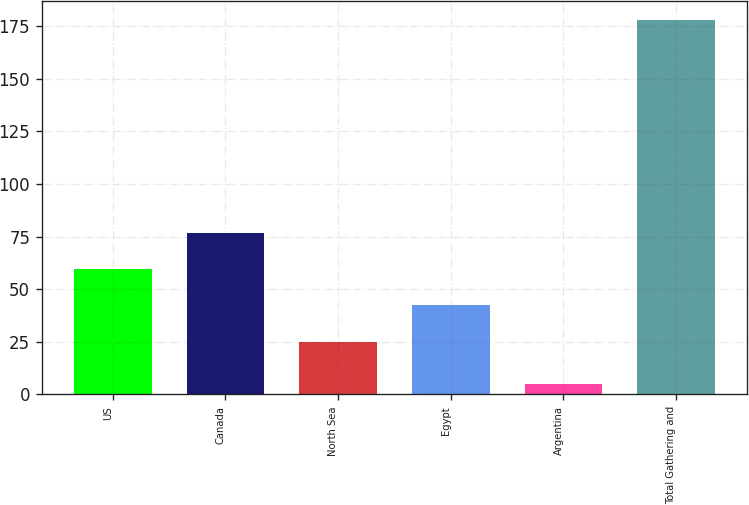<chart> <loc_0><loc_0><loc_500><loc_500><bar_chart><fcel>US<fcel>Canada<fcel>North Sea<fcel>Egypt<fcel>Argentina<fcel>Total Gathering and<nl><fcel>59.6<fcel>76.9<fcel>25<fcel>42.3<fcel>5<fcel>178<nl></chart> 